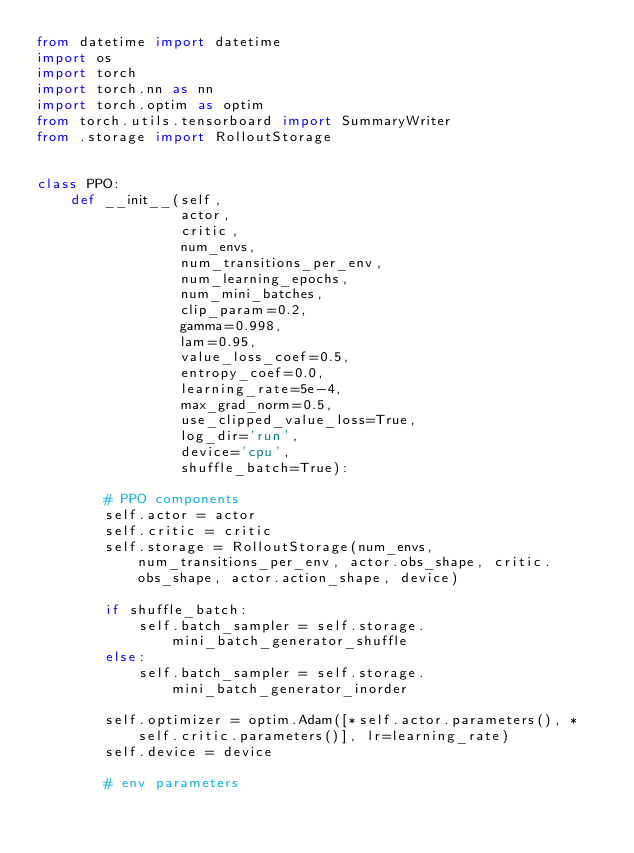<code> <loc_0><loc_0><loc_500><loc_500><_Python_>from datetime import datetime
import os
import torch
import torch.nn as nn
import torch.optim as optim
from torch.utils.tensorboard import SummaryWriter
from .storage import RolloutStorage


class PPO:
    def __init__(self,
                 actor,
                 critic,
                 num_envs,
                 num_transitions_per_env,
                 num_learning_epochs,
                 num_mini_batches,
                 clip_param=0.2,
                 gamma=0.998,
                 lam=0.95,
                 value_loss_coef=0.5,
                 entropy_coef=0.0,
                 learning_rate=5e-4,
                 max_grad_norm=0.5,
                 use_clipped_value_loss=True,
                 log_dir='run',
                 device='cpu',
                 shuffle_batch=True):

        # PPO components
        self.actor = actor
        self.critic = critic
        self.storage = RolloutStorage(num_envs, num_transitions_per_env, actor.obs_shape, critic.obs_shape, actor.action_shape, device)

        if shuffle_batch:
            self.batch_sampler = self.storage.mini_batch_generator_shuffle
        else:
            self.batch_sampler = self.storage.mini_batch_generator_inorder

        self.optimizer = optim.Adam([*self.actor.parameters(), *self.critic.parameters()], lr=learning_rate)
        self.device = device

        # env parameters</code> 